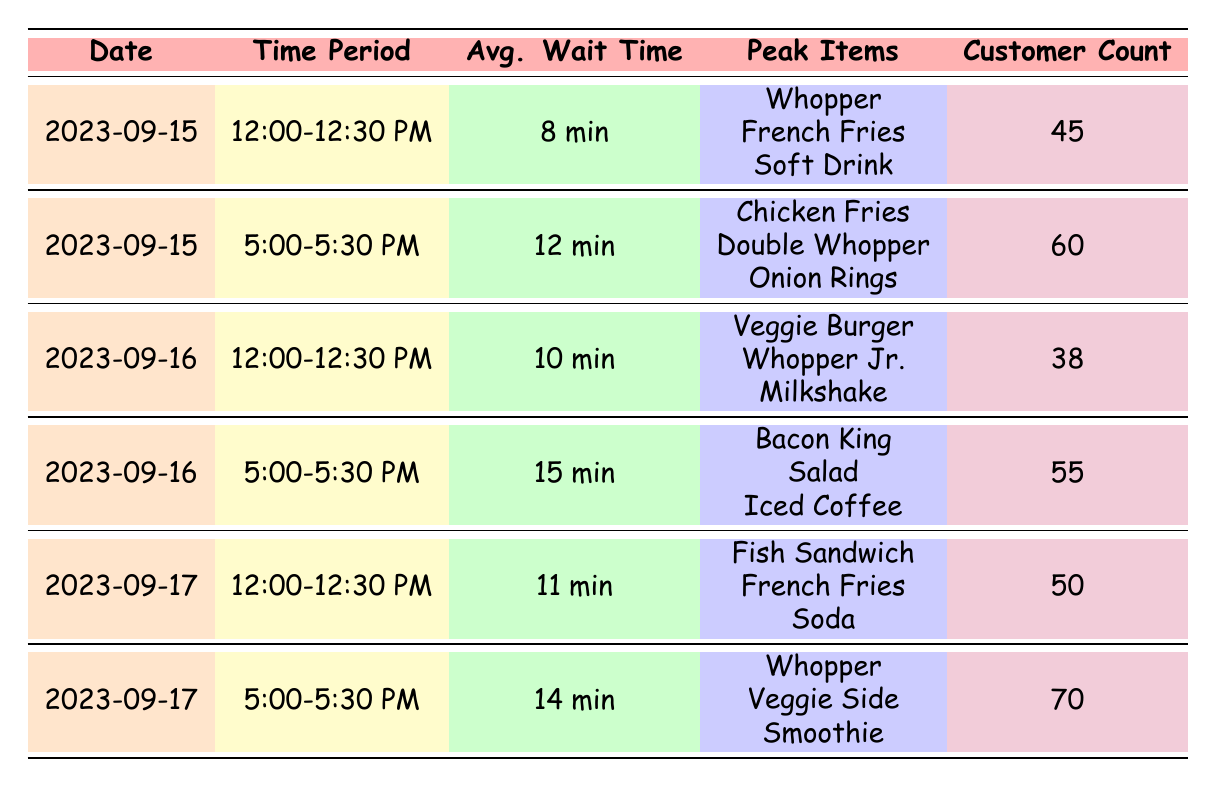What was the average wait time on September 15th during the 12:00-12:30 PM period? The table shows that on September 15th during the 12:00-12:30 PM period, the average wait time was listed as 8 minutes.
Answer: 8 minutes What are the peak items for the drive-thru orders on September 16th at 5:00-5:30 PM? According to the table, the peak items during that time period were Bacon King, Salad, and Iced Coffee.
Answer: Bacon King, Salad, Iced Coffee Which time period had the longest average wait time, and what was that wait time? By comparing all the average wait times, 5:00-5:30 PM on September 16th showed the longest wait time of 15 minutes.
Answer: 5:00-5:30 PM on September 16th, 15 minutes On which date did the highest customer count occur, and how many customers were there? The table indicates that the highest customer count was 70, which occurred on September 17th during the 5:00-5:30 PM period.
Answer: September 17th, 70 customers Is the average wait time for the 12:00-12:30 PM periods across all dates consistently less than 12 minutes? Reviewing the average wait times for 12:00-12:30 PM on the three dates shows values of 8, 10, and 11 minutes, all of which are indeed less than 12 minutes.
Answer: Yes What is the average wait time across all data provided in the table? To find the average wait time across all entries, we sum the wait times (8 + 12 + 10 + 15 + 11 + 14 = 70) and divide by the number of entries (6), resulting in an average wait time of 70/6 = approximately 11.67 minutes.
Answer: Approximately 11.67 minutes What item was common on the peak items for both time slots on September 15th? Looking at the peak items for both time slots on September 15th, the Whopper appears in both periods, making it the common item.
Answer: Whopper Which time period had the lowest average wait time and what was it? A close examination of the times reveals that the 12:00-12:30 PM period on September 15th had the lowest average wait time of 8 minutes.
Answer: 12:00-12:30 PM on September 15th, 8 minutes 